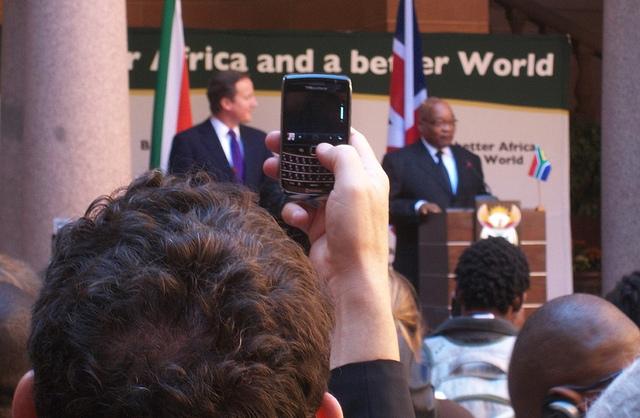What country is on the wall?
Keep it brief. Africa. Is this an international conference?
Be succinct. Yes. What kind of phone is the man holding up?
Keep it brief. Blackberry. 